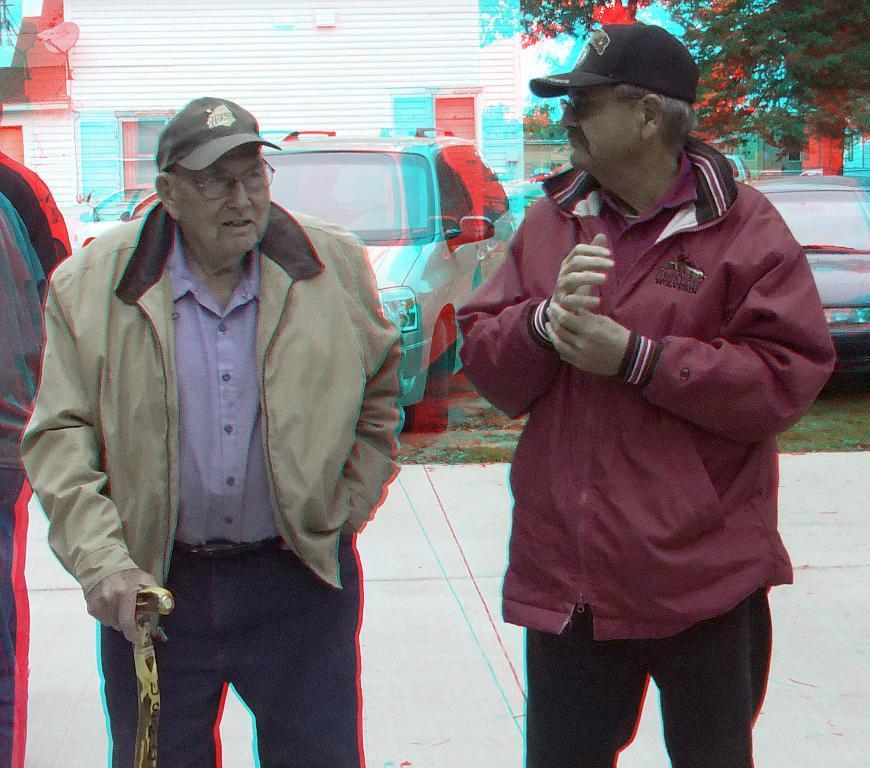Can you describe this image briefly? This is an edited image. The old man in violet shirt is holding a stick in his hand. Beside him, we see a man in maroon jacket is standing. Behind them, we see cars parked on the road. On the right side, there is a tree. In the background, we see a building in white color. 